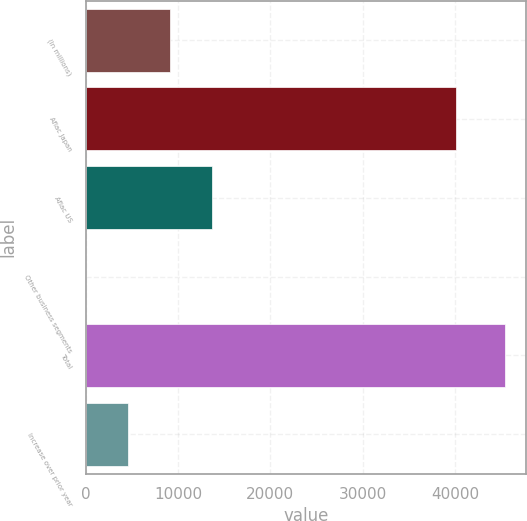Convert chart to OTSL. <chart><loc_0><loc_0><loc_500><loc_500><bar_chart><fcel>(In millions)<fcel>Aflac Japan<fcel>Aflac US<fcel>Other business segments<fcel>Total<fcel>Increase over prior year<nl><fcel>9090.4<fcel>40072<fcel>13634.1<fcel>3<fcel>45440<fcel>4546.7<nl></chart> 